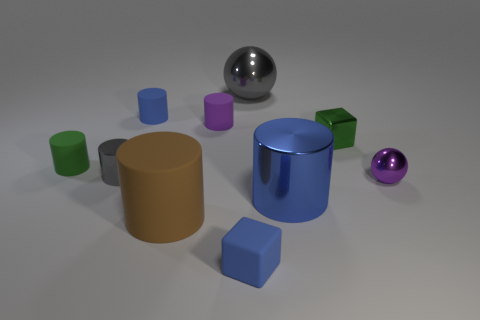Does the purple shiny thing have the same shape as the big gray metal thing?
Your response must be concise. Yes. What is the color of the rubber cylinder that is in front of the green metal thing and to the left of the large brown cylinder?
Give a very brief answer. Green. There is a matte object that is the same color as the tiny ball; what size is it?
Provide a succinct answer. Small. How many big objects are blue metal cubes or blue objects?
Ensure brevity in your answer.  1. Is there anything else of the same color as the small shiny block?
Your response must be concise. Yes. What is the material of the tiny green object on the right side of the gray metallic thing that is to the right of the metal cylinder to the left of the blue block?
Offer a terse response. Metal. How many metallic objects are big purple things or tiny objects?
Offer a terse response. 3. What number of blue objects are tiny cylinders or cylinders?
Your answer should be very brief. 2. Is the color of the large cylinder right of the big gray metallic object the same as the small matte cube?
Provide a short and direct response. Yes. Do the gray ball and the brown thing have the same material?
Ensure brevity in your answer.  No. 